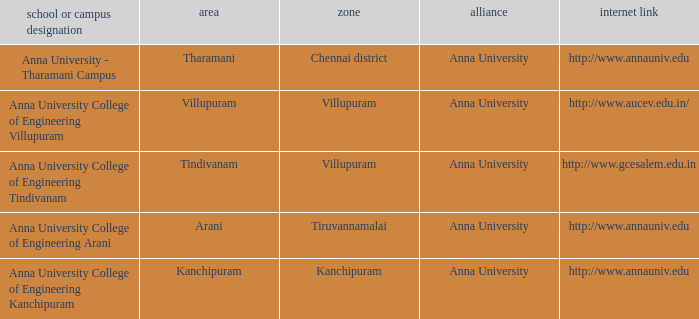What District has a College or Campus Name of anna university college of engineering kanchipuram? Kanchipuram. 